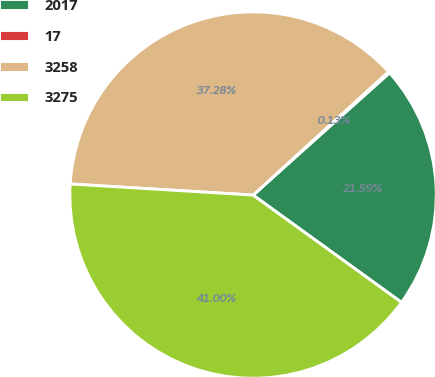Convert chart to OTSL. <chart><loc_0><loc_0><loc_500><loc_500><pie_chart><fcel>2017<fcel>17<fcel>3258<fcel>3275<nl><fcel>21.59%<fcel>0.13%<fcel>37.28%<fcel>41.0%<nl></chart> 